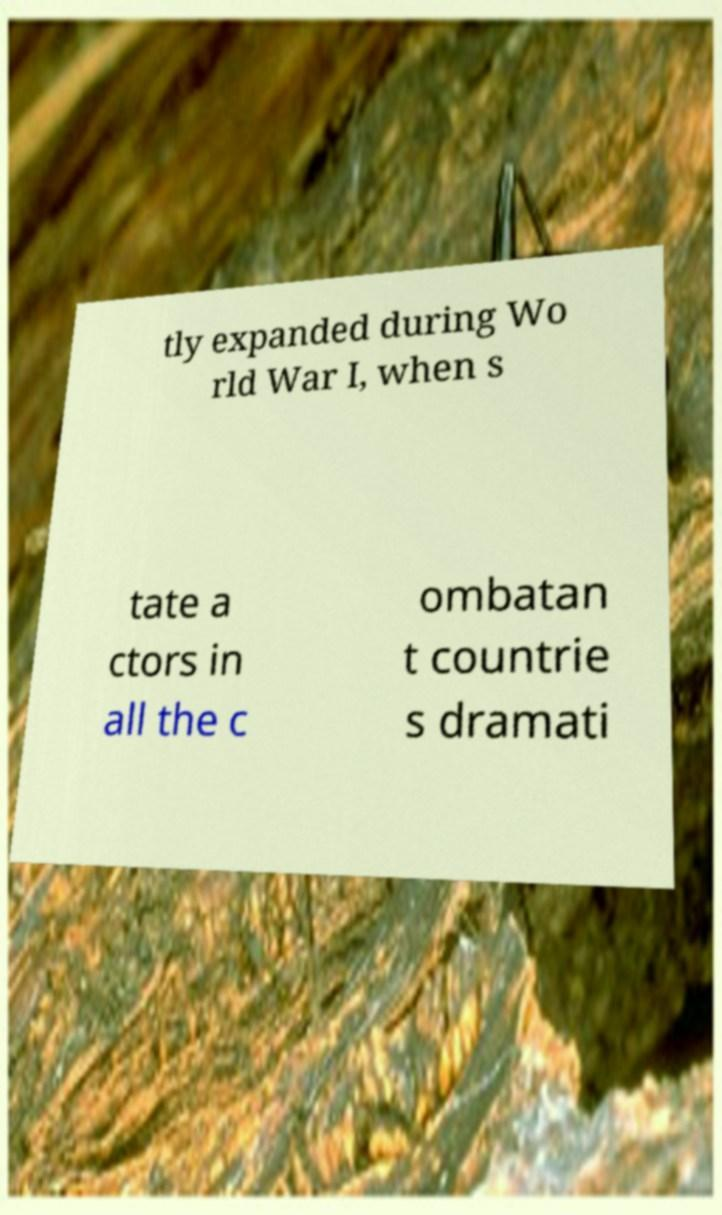For documentation purposes, I need the text within this image transcribed. Could you provide that? tly expanded during Wo rld War I, when s tate a ctors in all the c ombatan t countrie s dramati 